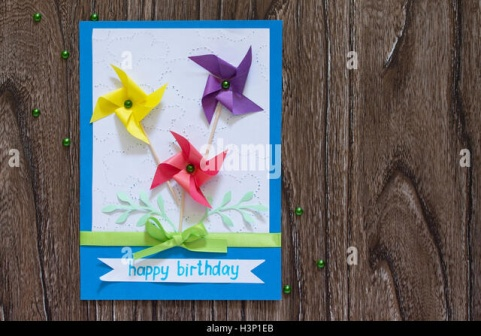Imagine if the green beads scattered around the card came to life. With a sprinkle of birthday magic, the tiny green beads around the card started to shimmer and shake. One by one, they sprang to life, bouncing and twinkling like miniature stars. These lively beads began to dance in a synchronized routine, creating patterns and shapes that told the story of a thousand birthdays, each one more magical than the last. They created rainbows, spiraled into shooting stars, and even spelled out 'happy birthday' in the air, adding an unforgettable spark to the celebration. How does the card's design contribute to its festive atmosphere? The design of the card is meticulously crafted to evoke a sense of celebration and joy. The vibrant, bold blue border contrasts beautifully with the clean, white center, drawing immediate attention to the cheerful 'happy birthday' message. The playful pinwheels in bright yellow, red, and purple add a whimsical touch, symbolizing childhood fun and carefree moments. The thoughtful addition of a green ribbon at the bottom not only enhances the aesthetic but also introduces a tactile element, fostering a deeper connection with the card. Scattered green beads around the card's periphery create a festive confetti-like effect, enhancing the overall celebratory theme. Together, these elements combine to create an atmosphere that is both joyful and inviting, perfect for marking a special birthday occasion. 